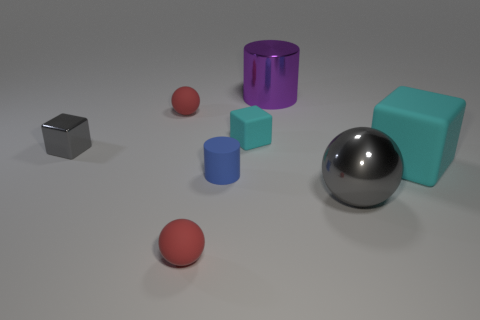There is a gray metal thing that is the same shape as the large cyan matte thing; what is its size?
Offer a very short reply. Small. What number of things are red matte objects behind the big gray object or cyan blocks to the right of the shiny cylinder?
Your answer should be very brief. 2. What size is the thing that is both right of the tiny cyan matte cube and in front of the tiny blue matte thing?
Your response must be concise. Large. Does the tiny metal thing have the same shape as the red matte object in front of the large matte thing?
Your answer should be very brief. No. What number of objects are either large metal balls to the right of the shiny cylinder or gray cubes?
Your response must be concise. 2. Do the gray cube and the red thing that is behind the blue rubber cylinder have the same material?
Make the answer very short. No. There is a cyan object that is right of the small matte block that is left of the big cyan thing; what shape is it?
Provide a short and direct response. Cube. There is a tiny metal thing; is it the same color as the cylinder that is in front of the small gray block?
Provide a short and direct response. No. Is there anything else that has the same material as the small gray object?
Your answer should be compact. Yes. What shape is the big purple metallic object?
Offer a terse response. Cylinder. 